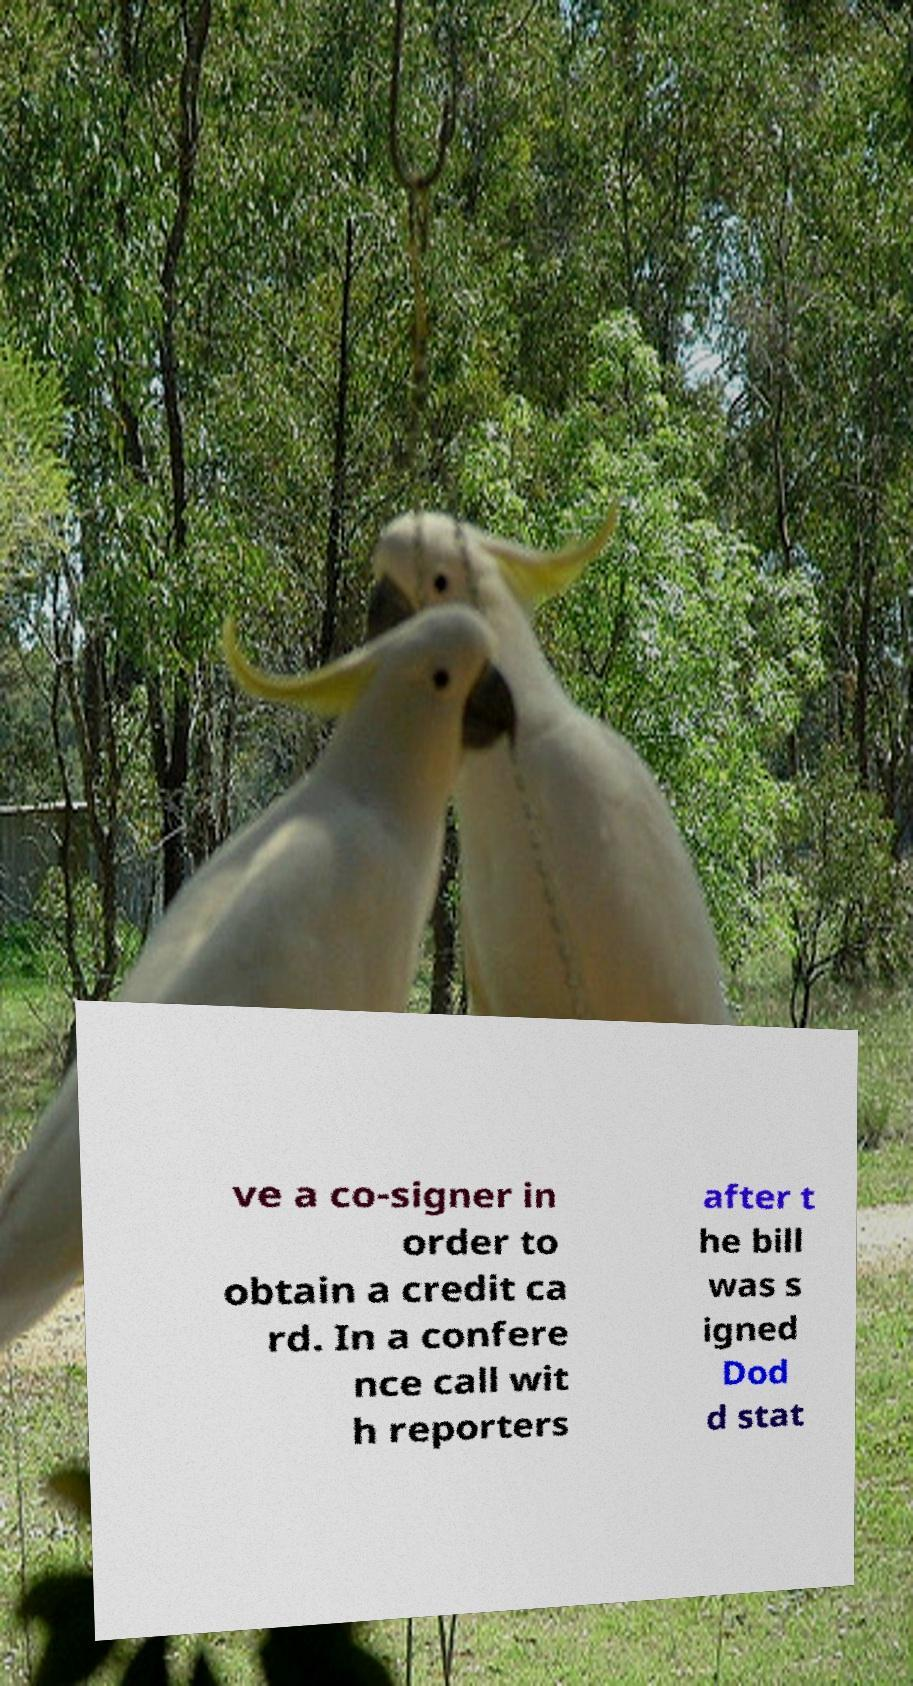Could you assist in decoding the text presented in this image and type it out clearly? ve a co-signer in order to obtain a credit ca rd. In a confere nce call wit h reporters after t he bill was s igned Dod d stat 